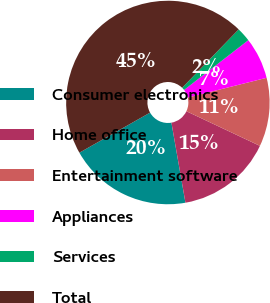Convert chart to OTSL. <chart><loc_0><loc_0><loc_500><loc_500><pie_chart><fcel>Consumer electronics<fcel>Home office<fcel>Entertainment software<fcel>Appliances<fcel>Services<fcel>Total<nl><fcel>19.55%<fcel>15.23%<fcel>10.91%<fcel>6.59%<fcel>2.27%<fcel>45.45%<nl></chart> 